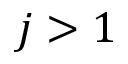Convert formula to latex. <formula><loc_0><loc_0><loc_500><loc_500>j > 1</formula> 